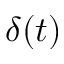Convert formula to latex. <formula><loc_0><loc_0><loc_500><loc_500>\delta ( t )</formula> 